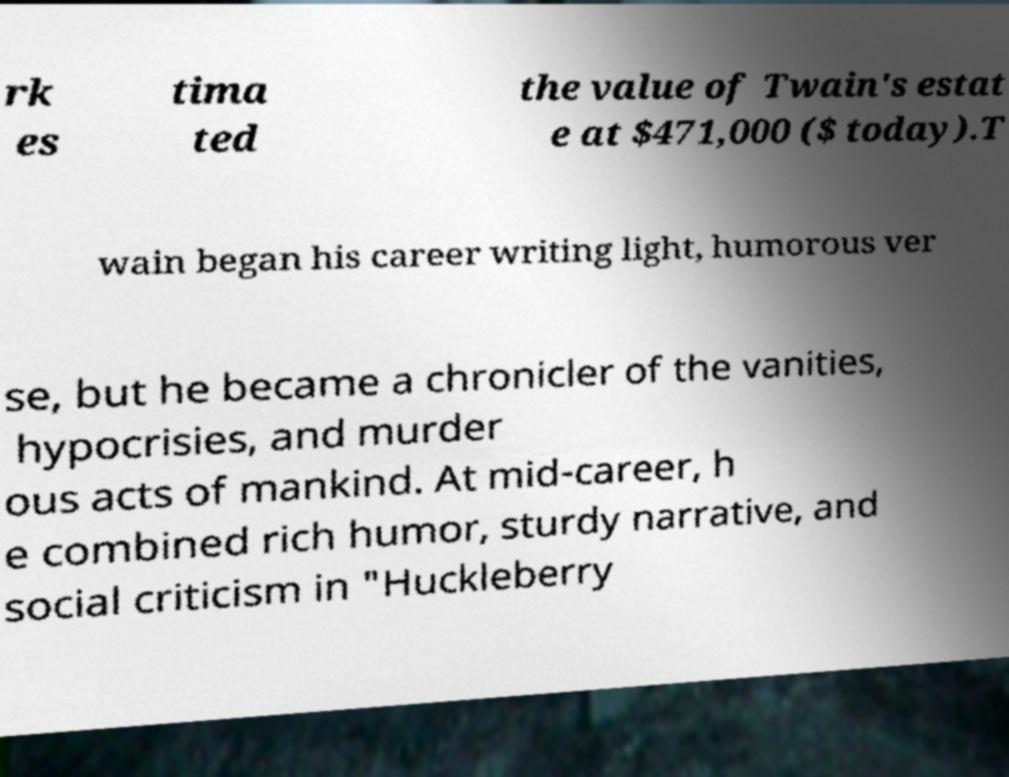Can you accurately transcribe the text from the provided image for me? rk es tima ted the value of Twain's estat e at $471,000 ($ today).T wain began his career writing light, humorous ver se, but he became a chronicler of the vanities, hypocrisies, and murder ous acts of mankind. At mid-career, h e combined rich humor, sturdy narrative, and social criticism in "Huckleberry 